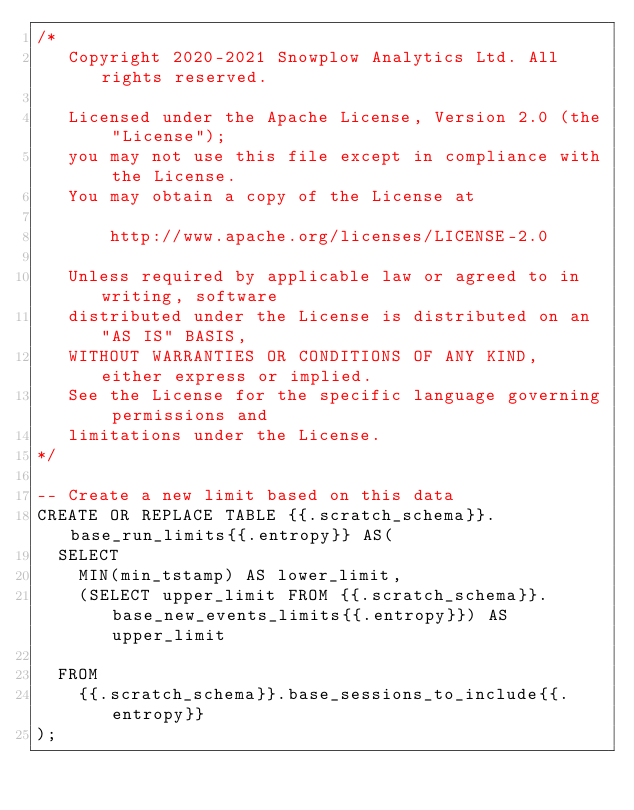Convert code to text. <code><loc_0><loc_0><loc_500><loc_500><_SQL_>/*
   Copyright 2020-2021 Snowplow Analytics Ltd. All rights reserved.

   Licensed under the Apache License, Version 2.0 (the "License");
   you may not use this file except in compliance with the License.
   You may obtain a copy of the License at

       http://www.apache.org/licenses/LICENSE-2.0

   Unless required by applicable law or agreed to in writing, software
   distributed under the License is distributed on an "AS IS" BASIS,
   WITHOUT WARRANTIES OR CONDITIONS OF ANY KIND, either express or implied.
   See the License for the specific language governing permissions and
   limitations under the License.
*/

-- Create a new limit based on this data
CREATE OR REPLACE TABLE {{.scratch_schema}}.base_run_limits{{.entropy}} AS(
  SELECT
    MIN(min_tstamp) AS lower_limit,
    (SELECT upper_limit FROM {{.scratch_schema}}.base_new_events_limits{{.entropy}}) AS upper_limit

  FROM
    {{.scratch_schema}}.base_sessions_to_include{{.entropy}}
);
</code> 